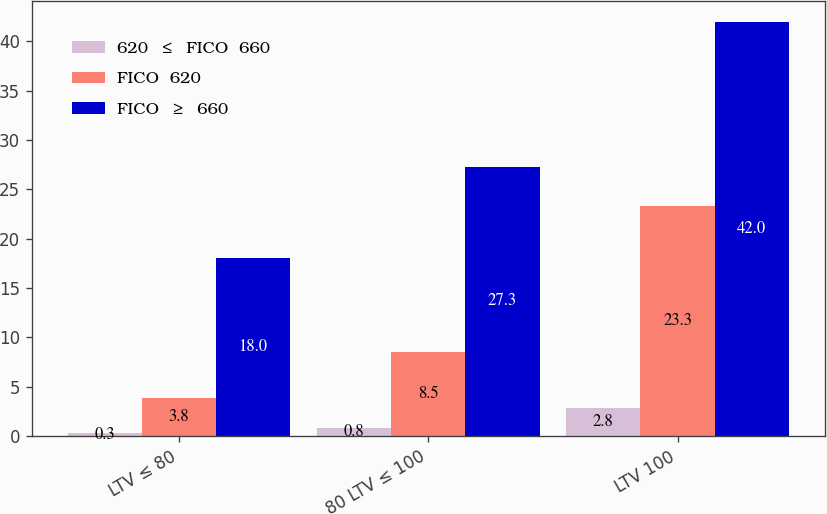<chart> <loc_0><loc_0><loc_500><loc_500><stacked_bar_chart><ecel><fcel>LTV ≤ 80<fcel>80 LTV ≤ 100<fcel>LTV 100<nl><fcel>620  ≤  FICO  660<fcel>0.3<fcel>0.8<fcel>2.8<nl><fcel>FICO  620<fcel>3.8<fcel>8.5<fcel>23.3<nl><fcel>FICO  ≥  660<fcel>18<fcel>27.3<fcel>42<nl></chart> 